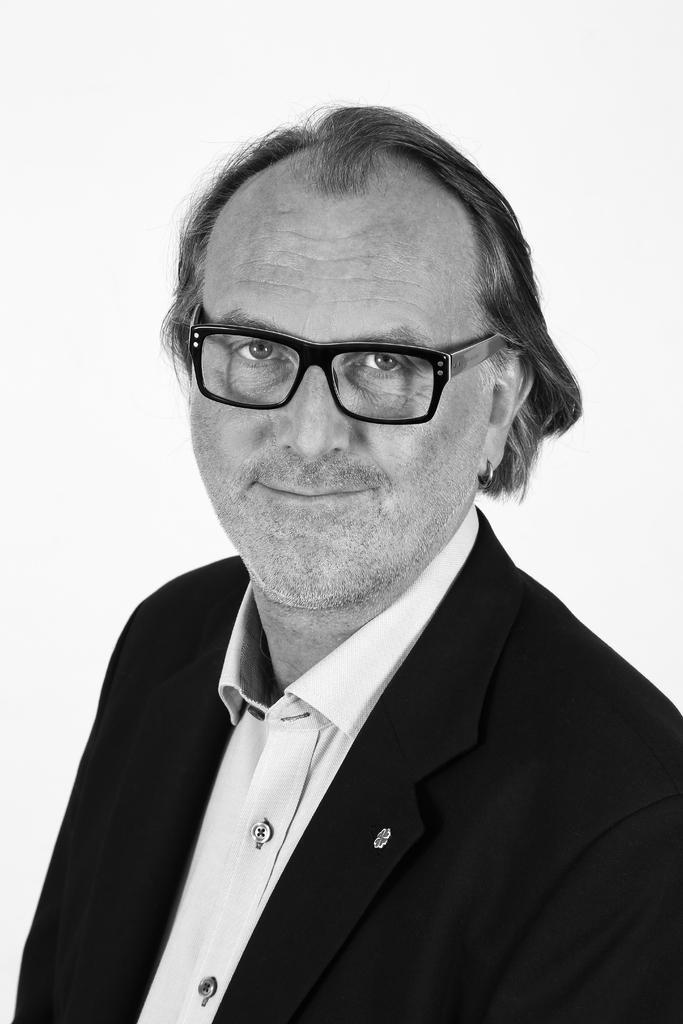Can you describe this image briefly? It is a black and white image, there is a man posing for the photo. He is wearing spectacles. 